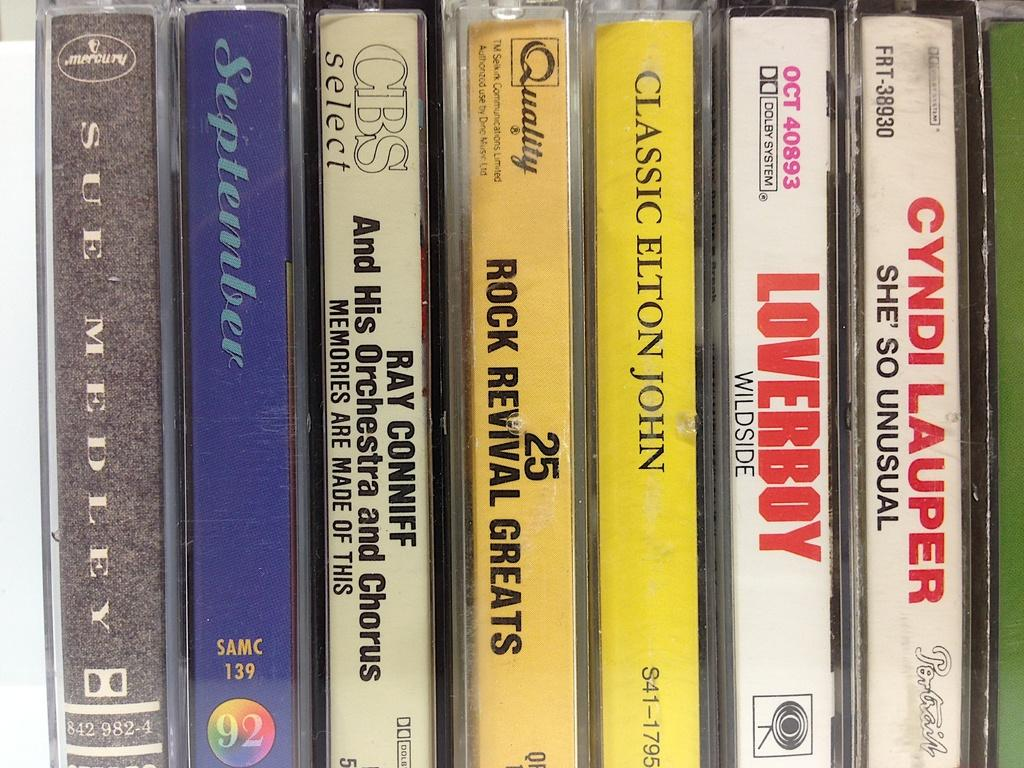Provide a one-sentence caption for the provided image. A set of old cassettes, one of which is called September. 